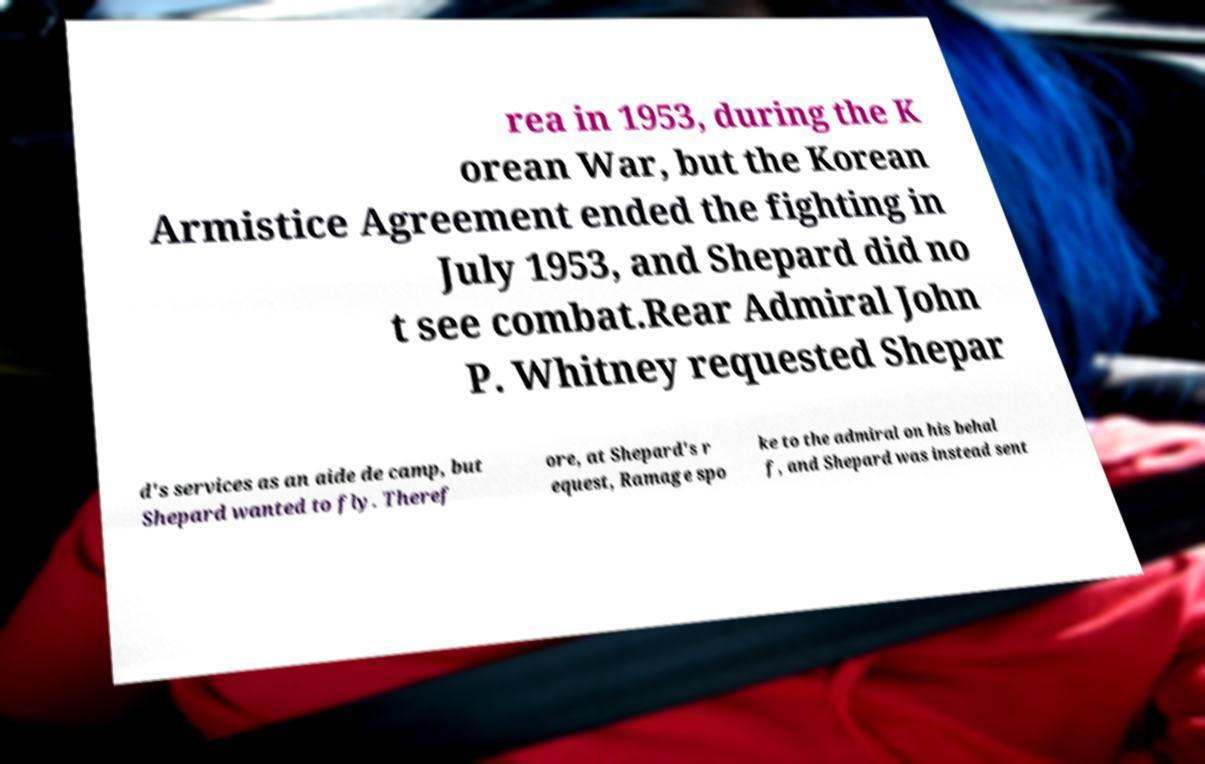What messages or text are displayed in this image? I need them in a readable, typed format. rea in 1953, during the K orean War, but the Korean Armistice Agreement ended the fighting in July 1953, and Shepard did no t see combat.Rear Admiral John P. Whitney requested Shepar d's services as an aide de camp, but Shepard wanted to fly. Theref ore, at Shepard's r equest, Ramage spo ke to the admiral on his behal f, and Shepard was instead sent 